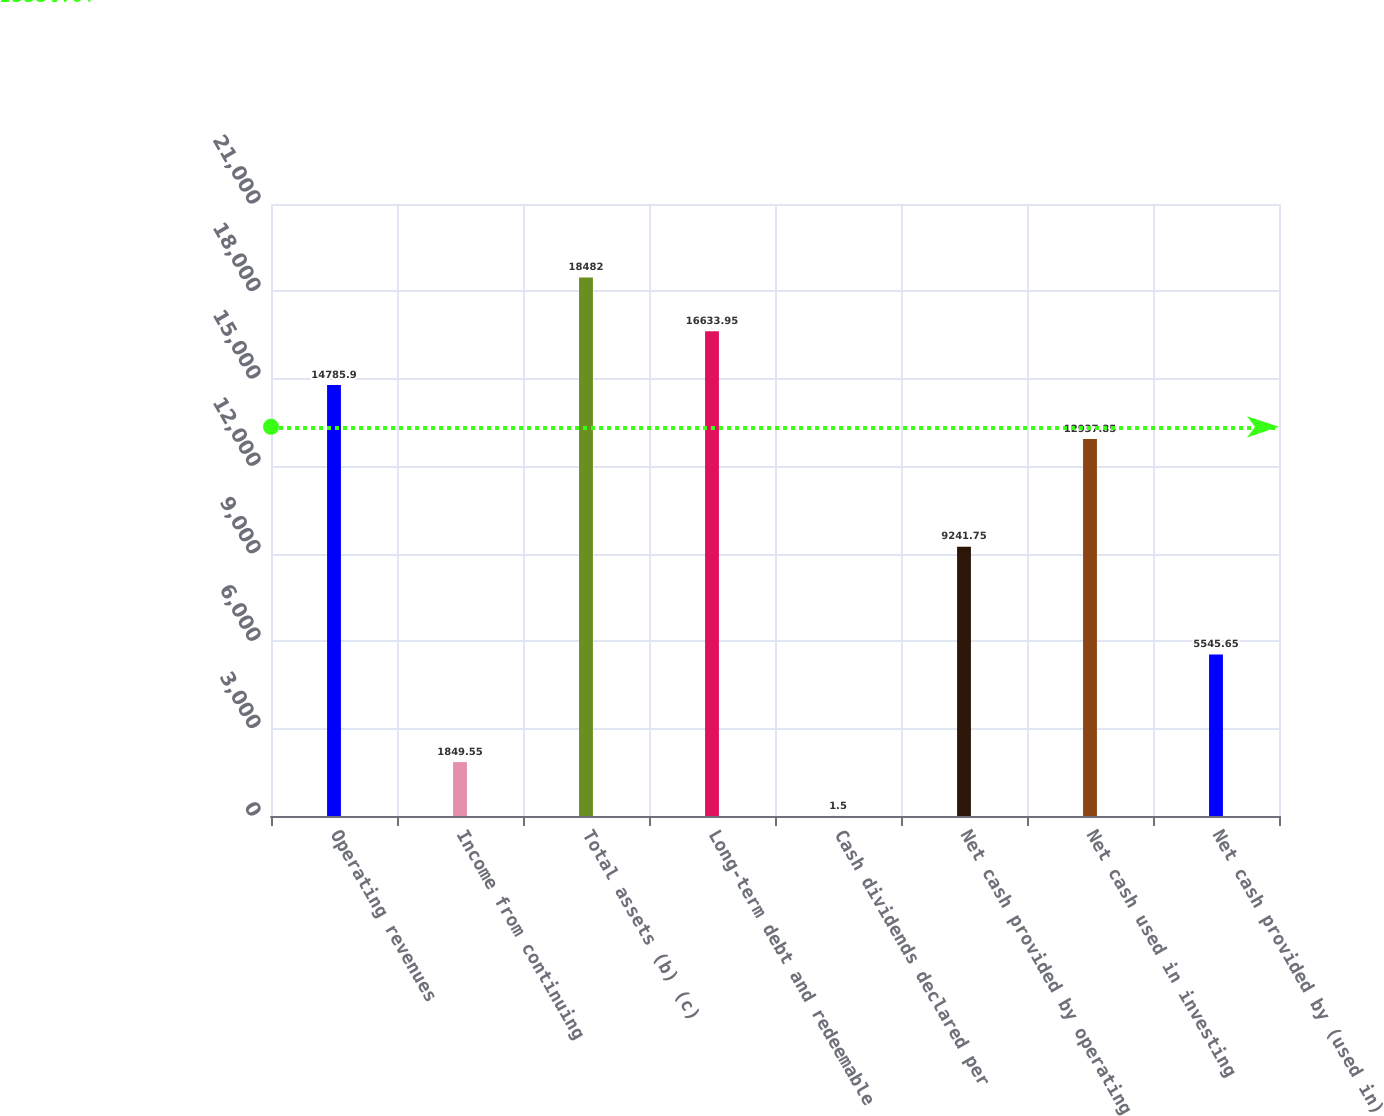Convert chart. <chart><loc_0><loc_0><loc_500><loc_500><bar_chart><fcel>Operating revenues<fcel>Income from continuing<fcel>Total assets (b) (c)<fcel>Long-term debt and redeemable<fcel>Cash dividends declared per<fcel>Net cash provided by operating<fcel>Net cash used in investing<fcel>Net cash provided by (used in)<nl><fcel>14785.9<fcel>1849.55<fcel>18482<fcel>16634<fcel>1.5<fcel>9241.75<fcel>12937.9<fcel>5545.65<nl></chart> 